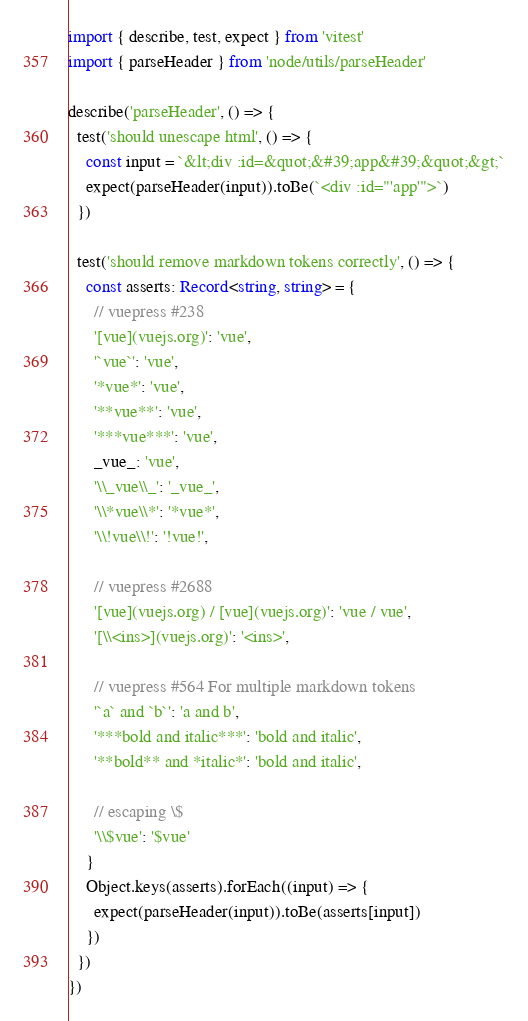Convert code to text. <code><loc_0><loc_0><loc_500><loc_500><_TypeScript_>import { describe, test, expect } from 'vitest'
import { parseHeader } from 'node/utils/parseHeader'

describe('parseHeader', () => {
  test('should unescape html', () => {
    const input = `&lt;div :id=&quot;&#39;app&#39;&quot;&gt;`
    expect(parseHeader(input)).toBe(`<div :id="'app'">`)
  })

  test('should remove markdown tokens correctly', () => {
    const asserts: Record<string, string> = {
      // vuepress #238
      '[vue](vuejs.org)': 'vue',
      '`vue`': 'vue',
      '*vue*': 'vue',
      '**vue**': 'vue',
      '***vue***': 'vue',
      _vue_: 'vue',
      '\\_vue\\_': '_vue_',
      '\\*vue\\*': '*vue*',
      '\\!vue\\!': '!vue!',

      // vuepress #2688
      '[vue](vuejs.org) / [vue](vuejs.org)': 'vue / vue',
      '[\\<ins>](vuejs.org)': '<ins>',

      // vuepress #564 For multiple markdown tokens
      '`a` and `b`': 'a and b',
      '***bold and italic***': 'bold and italic',
      '**bold** and *italic*': 'bold and italic',

      // escaping \$
      '\\$vue': '$vue'
    }
    Object.keys(asserts).forEach((input) => {
      expect(parseHeader(input)).toBe(asserts[input])
    })
  })
})
</code> 